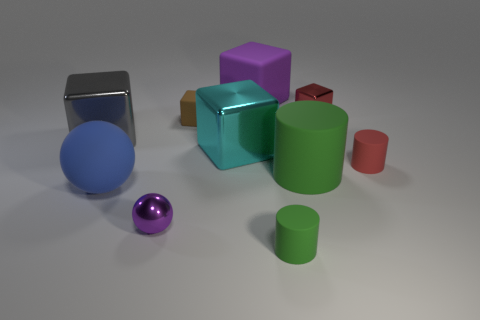Is the color of the big rubber cube the same as the matte ball?
Ensure brevity in your answer.  No. Is there anything else that is the same shape as the large cyan metallic thing?
Make the answer very short. Yes. Is the number of gray cubes less than the number of yellow rubber cubes?
Provide a succinct answer. No. There is a small metallic object that is right of the big metallic cube in front of the gray block; what color is it?
Offer a terse response. Red. What material is the large cube that is left of the purple object in front of the shiny block in front of the gray shiny block?
Keep it short and to the point. Metal. There is a ball that is to the left of the purple metal thing; does it have the same size as the purple metal sphere?
Offer a terse response. No. There is a tiny brown object that is behind the large gray cube; what material is it?
Your answer should be compact. Rubber. Is the number of blue balls greater than the number of blue metallic cylinders?
Your answer should be very brief. Yes. What number of objects are tiny matte cylinders to the right of the big cylinder or blue spheres?
Ensure brevity in your answer.  2. What number of small blocks are to the left of the large thing that is in front of the large green object?
Offer a terse response. 0. 